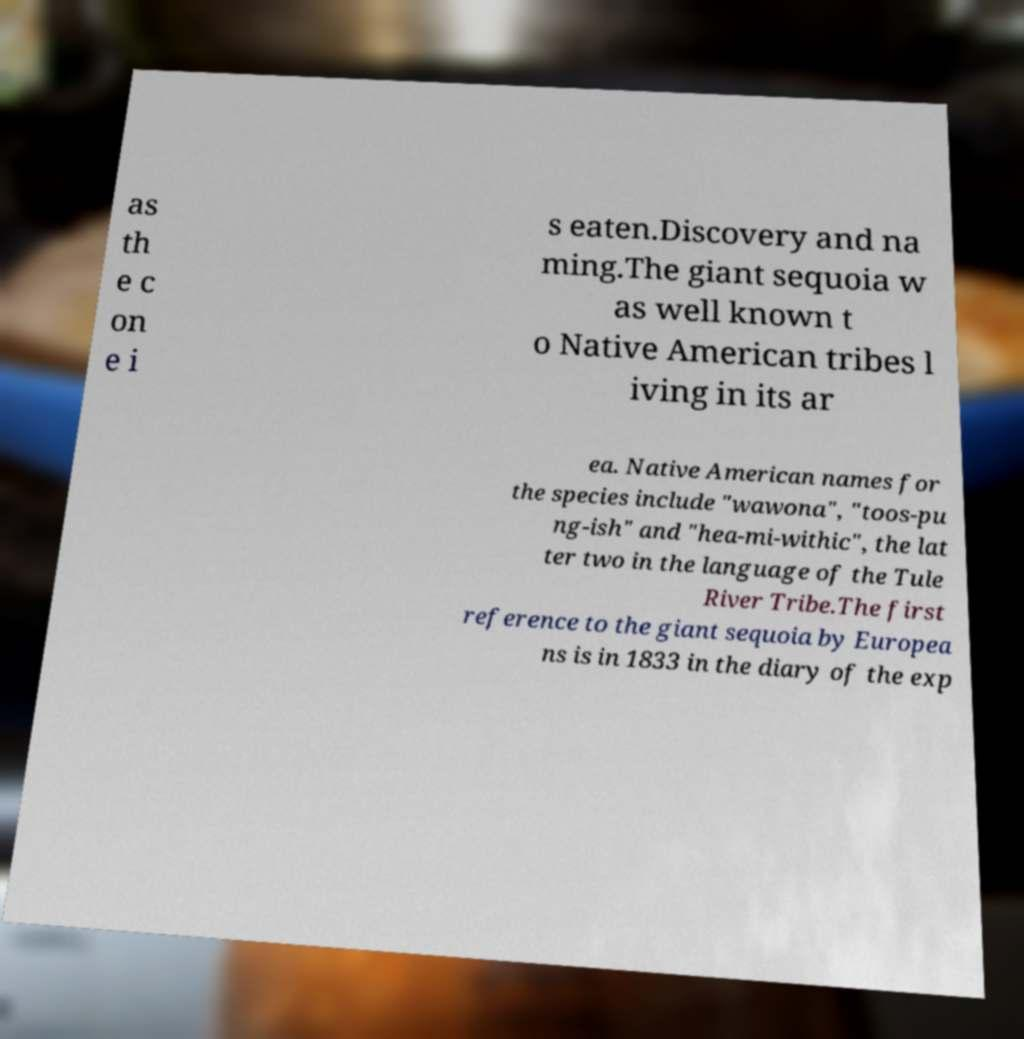Please read and relay the text visible in this image. What does it say? as th e c on e i s eaten.Discovery and na ming.The giant sequoia w as well known t o Native American tribes l iving in its ar ea. Native American names for the species include "wawona", "toos-pu ng-ish" and "hea-mi-withic", the lat ter two in the language of the Tule River Tribe.The first reference to the giant sequoia by Europea ns is in 1833 in the diary of the exp 